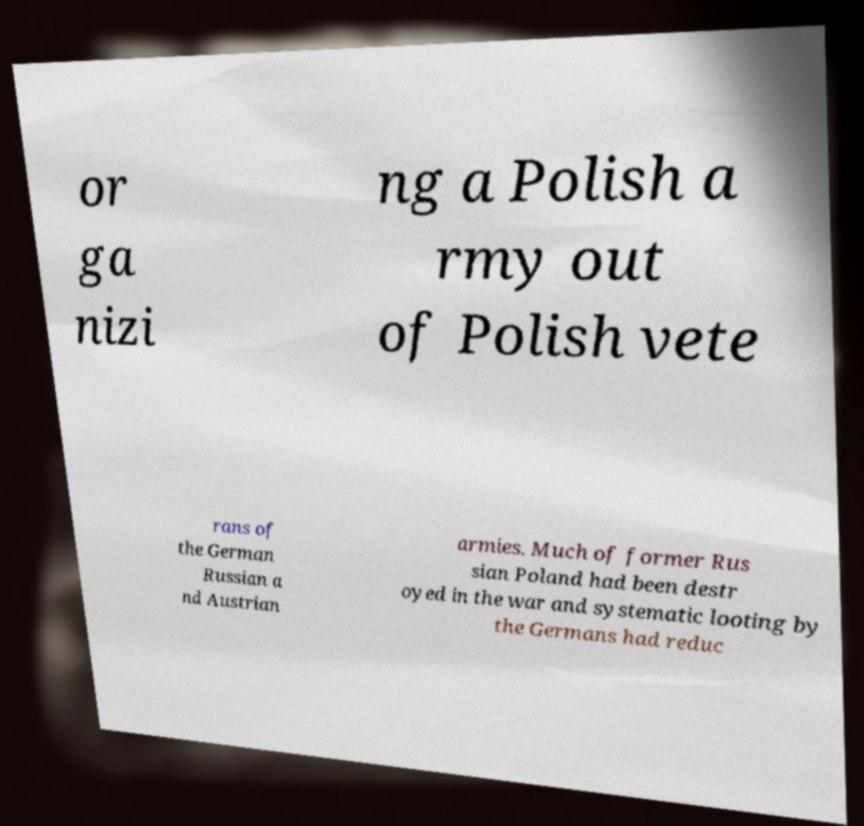Can you read and provide the text displayed in the image?This photo seems to have some interesting text. Can you extract and type it out for me? or ga nizi ng a Polish a rmy out of Polish vete rans of the German Russian a nd Austrian armies. Much of former Rus sian Poland had been destr oyed in the war and systematic looting by the Germans had reduc 